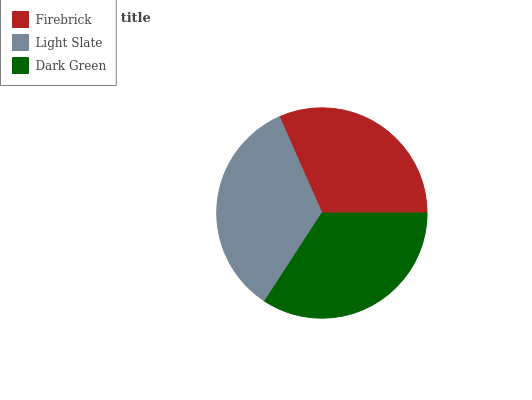Is Firebrick the minimum?
Answer yes or no. Yes. Is Light Slate the maximum?
Answer yes or no. Yes. Is Dark Green the minimum?
Answer yes or no. No. Is Dark Green the maximum?
Answer yes or no. No. Is Light Slate greater than Dark Green?
Answer yes or no. Yes. Is Dark Green less than Light Slate?
Answer yes or no. Yes. Is Dark Green greater than Light Slate?
Answer yes or no. No. Is Light Slate less than Dark Green?
Answer yes or no. No. Is Dark Green the high median?
Answer yes or no. Yes. Is Dark Green the low median?
Answer yes or no. Yes. Is Firebrick the high median?
Answer yes or no. No. Is Light Slate the low median?
Answer yes or no. No. 